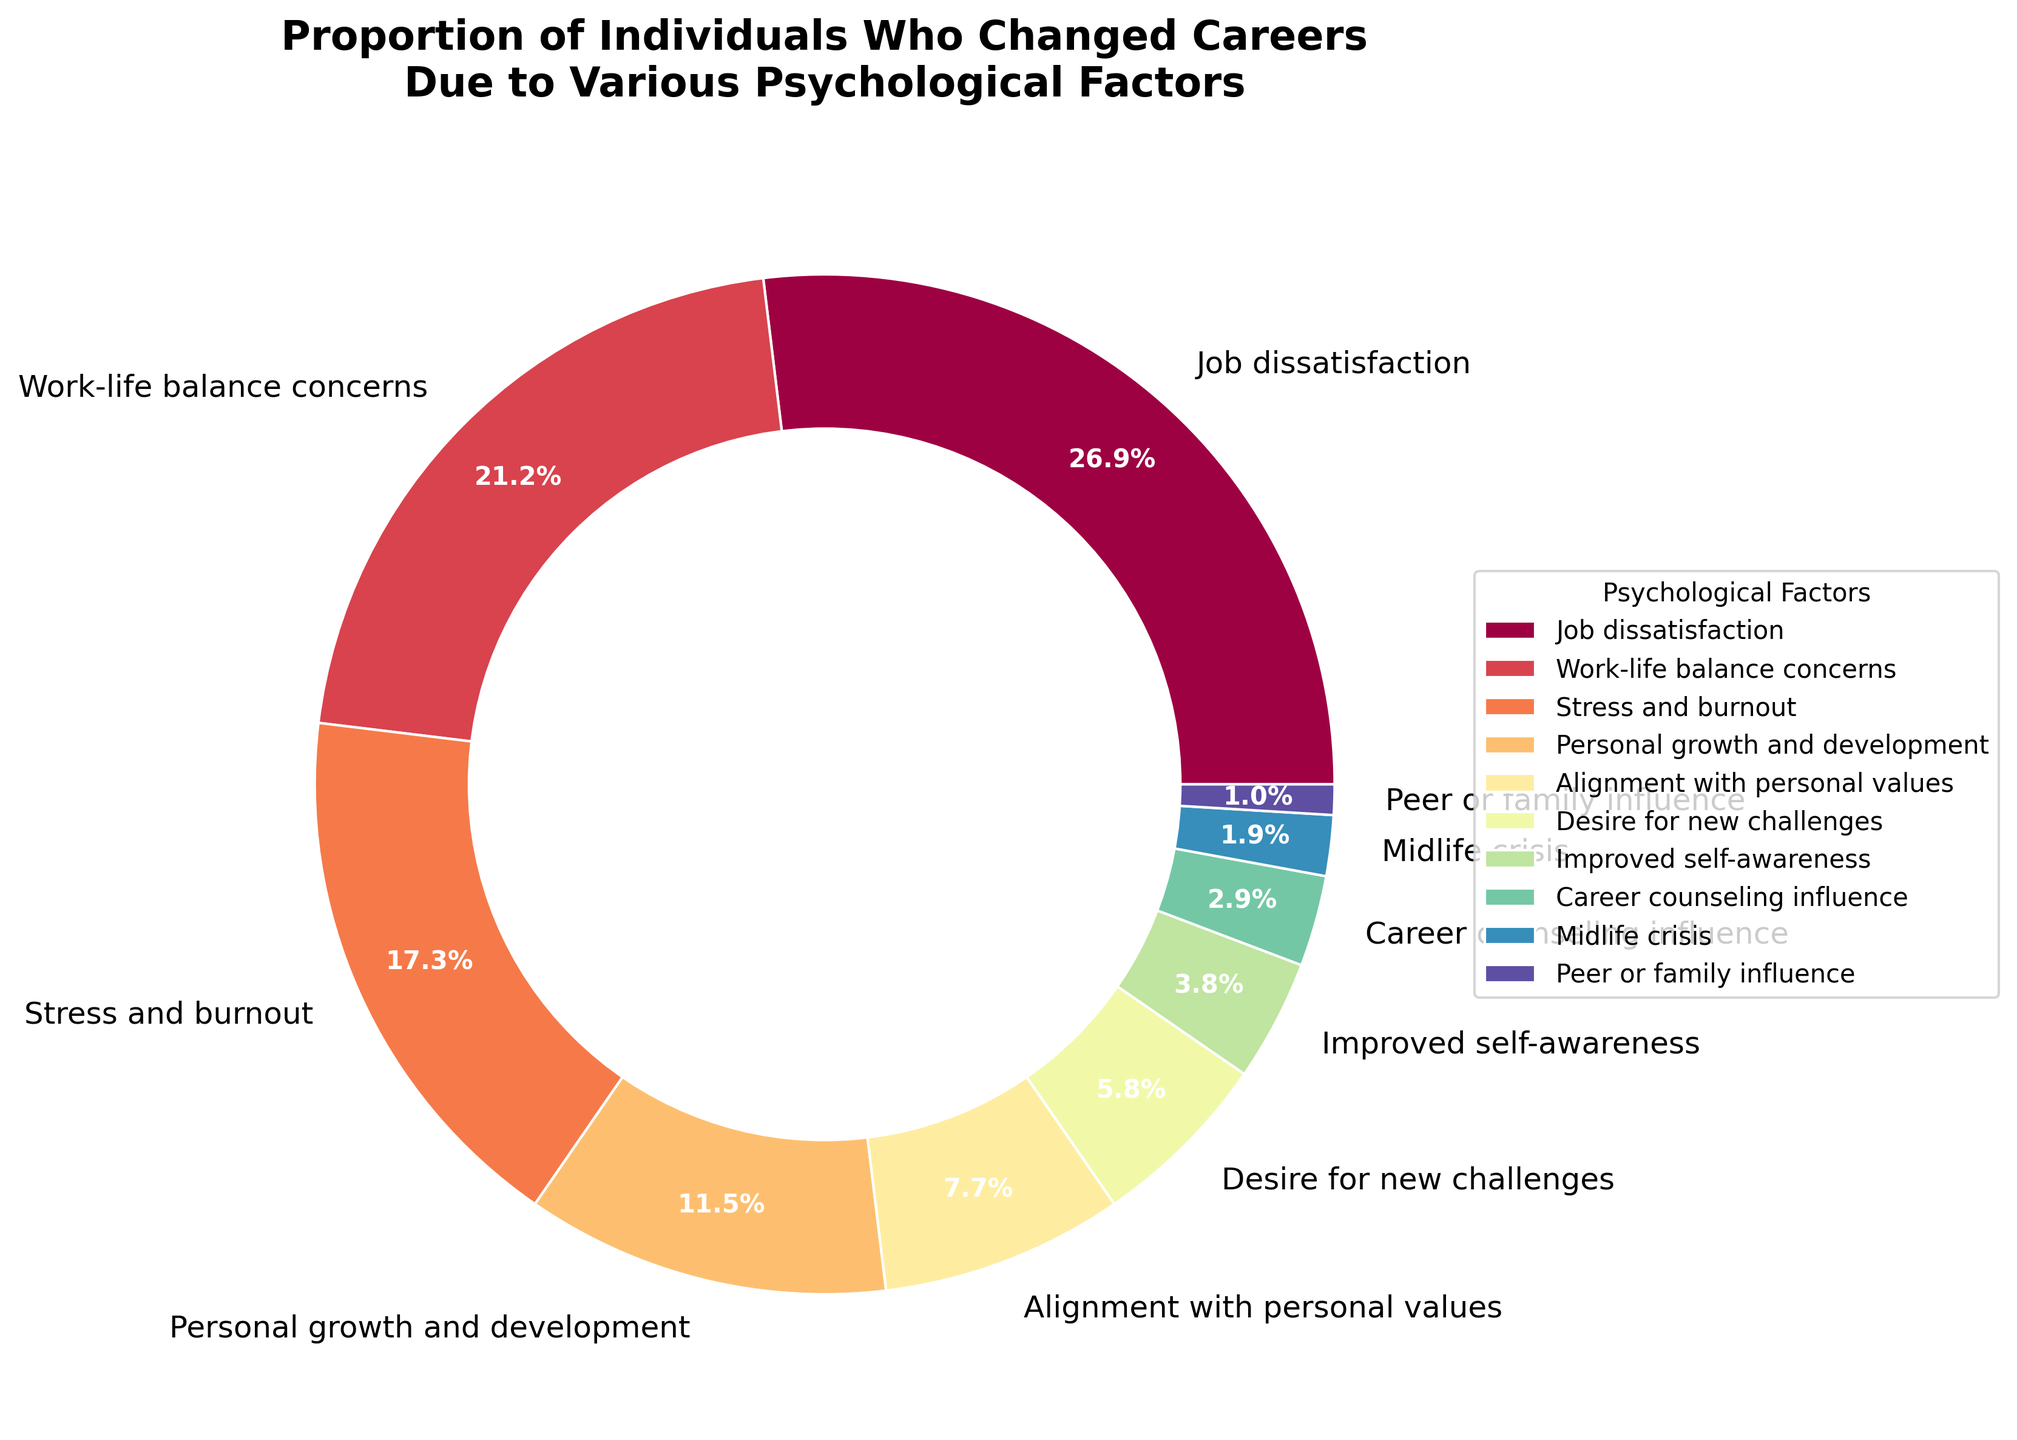Which psychological factor has the highest proportion of individuals who changed careers? Identify the largest section in the pie chart. The section labeled "Job dissatisfaction" has the highest percentage.
Answer: Job dissatisfaction Which psychological factor accounts for the smallest proportion of career changes? Identify the smallest section in the pie chart. The section labeled "Peer or family influence" is the smallest.
Answer: Peer or family influence What is the combined percentage of individuals who changed careers due to 'Job dissatisfaction' and 'Work-life balance concerns'? Sum the percentages for "Job dissatisfaction" and "Work-life balance concerns". 28% + 22% = 50%
Answer: 50% How does the proportion of individuals citing 'Stress and burnout' as a factor compare to those citing 'Personal growth and development'? Compare the percentages of "Stress and burnout" (18%) and "Personal growth and development" (12%). ‘Stress and burnout’ has a higher percentage.
Answer: Stress and burnout Order the psychological factors from highest to lowest percentage. List all factors in descending order of their percentages: Job dissatisfaction (28%), Work-life balance concerns (22%), Stress and burnout (18%), Personal growth and development (12%), Alignment with personal values (8%), Desire for new challenges (6%), Improved self-awareness (4%), Career counseling influence (3%), Midlife crisis (2%), Peer or family influence (1%).
Answer: Job dissatisfaction, Work-life balance concerns, Stress and burnout, Personal growth and development, Alignment with personal values, Desire for new challenges, Improved self-awareness, Career counseling influence, Midlife crisis, Peer or family influence What are the top three psychological factors causing career changes? Identify the top three largest sections in the pie chart. They are "Job dissatisfaction" (28%), "Work-life balance concerns" (22%), and "Stress and burnout" (18%).
Answer: Job dissatisfaction, Work-life balance concerns, Stress and burnout If you combine the percentages of 'Desire for new challenges', 'Improved self-awareness', and 'Career counseling influence', what is the total proportion? Sum the percentages for "Desire for new challenges" (6%), "Improved self-awareness" (4%), and "Career counseling influence" (3%). 6% + 4% + 3% = 13%
Answer: 13% Which psychological factor is linked to the least stress-related career changes, based on the provided data? Consider "Stress and burnout" as a stress-related factor and identify the smallest percentage-linked factor that is not related to stress. "Peer or family influence" at 1% is the smallest factor.
Answer: Peer or family influence How does 'Personal growth and development' compare with 'Alignment with personal values' in terms of percentage points difference? Calculate the difference between "Personal growth and development" (12%) and "Alignment with personal values" (8%). 12% - 8% = 4%
Answer: 4% Combining 'Midlife crisis' and 'Peer or family influence', is the total percentage greater or lesser than 'Desire for new challenges'? Sum the percentages for "Midlife crisis" (2%) and "Peer or family influence" (1%). Compare the total (3%) to "Desire for new challenges" (6%). 2% + 1% = 3%, which is less than 6%.
Answer: Lesser 